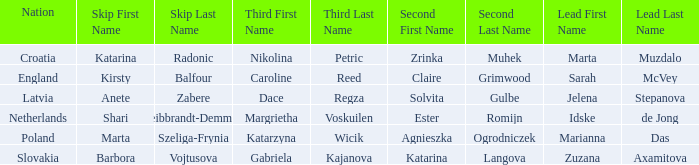Who is the Second with Nikolina Petric as Third? Zrinka Muhek. 